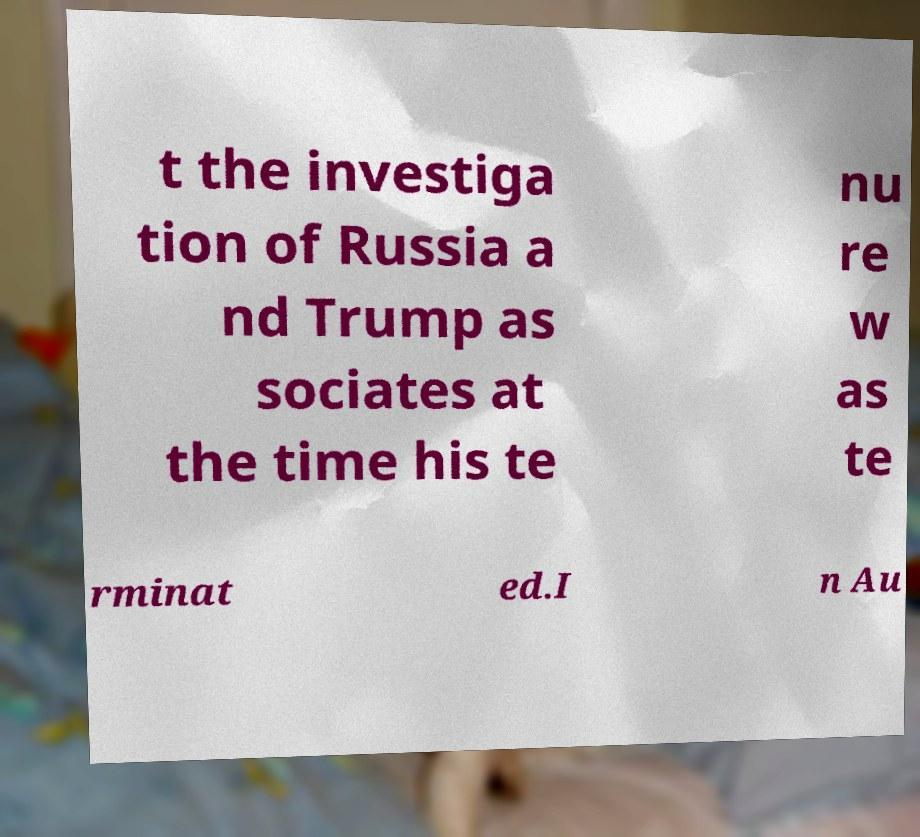Can you read and provide the text displayed in the image?This photo seems to have some interesting text. Can you extract and type it out for me? t the investiga tion of Russia a nd Trump as sociates at the time his te nu re w as te rminat ed.I n Au 